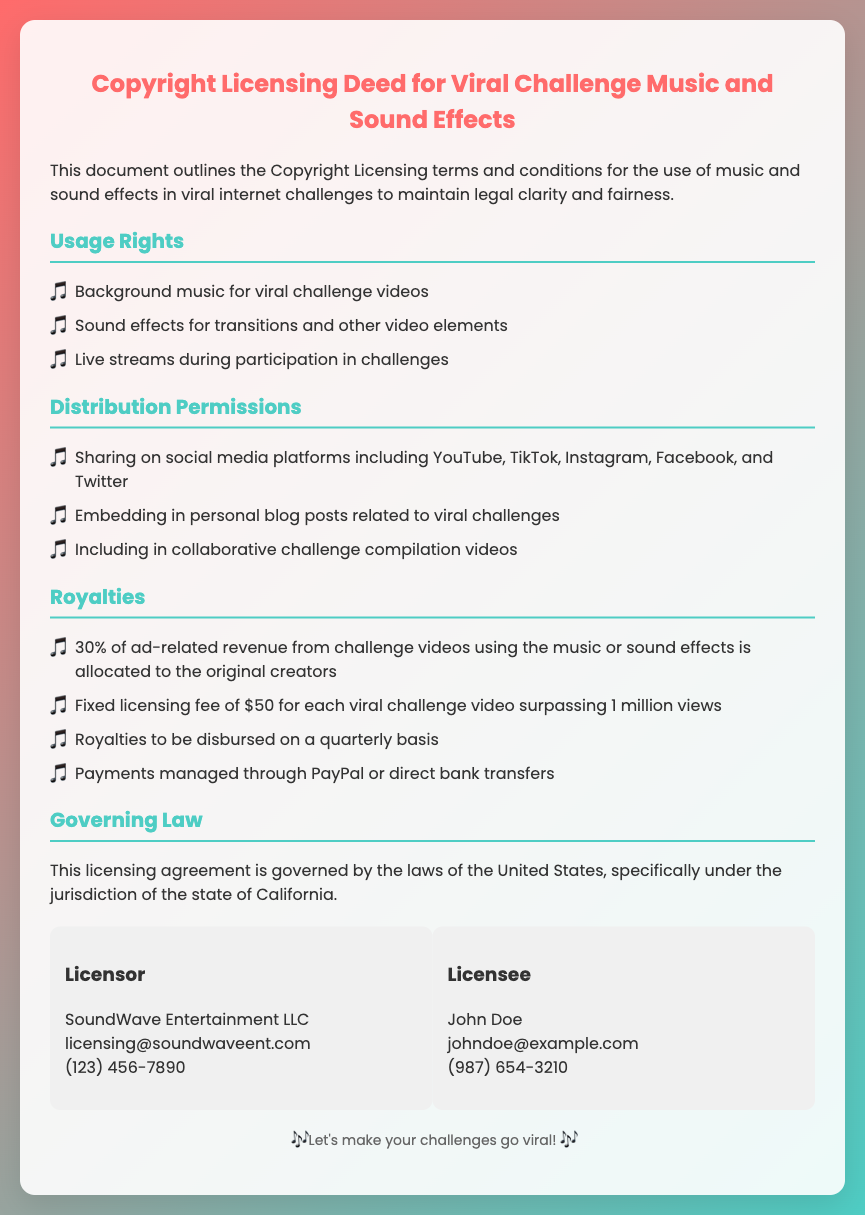what is the fixed licensing fee for videos surpassing one million views? The fixed licensing fee mentioned in the document specifically for viral challenge videos surpassing one million views is $50.
Answer: $50 who is the licensor? The document identifies SoundWave Entertainment LLC as the licensor.
Answer: SoundWave Entertainment LLC what percentage of ad-related revenue do original creators receive? According to the document, original creators are allocated 30% of ad-related revenue from challenge videos using the music or sound effects.
Answer: 30% which state governs this licensing agreement? The licensing agreement is governed by the laws of California, as stated in the document.
Answer: California on which platforms can music and sound effects be shared? The document lists platforms where music and sound effects can be shared, including YouTube, TikTok, Instagram, Facebook, and Twitter.
Answer: YouTube, TikTok, Instagram, Facebook, Twitter how often are royalties to be disbursed? The document specifies that royalties will be disbursed on a quarterly basis.
Answer: Quarterly what is the main purpose of this document? The document outlines the Copyright Licensing terms and conditions for the use of music and sound effects in viral internet challenges.
Answer: Legal clarity and fairness who is the licensee? The document names John Doe as the licensee.
Answer: John Doe 